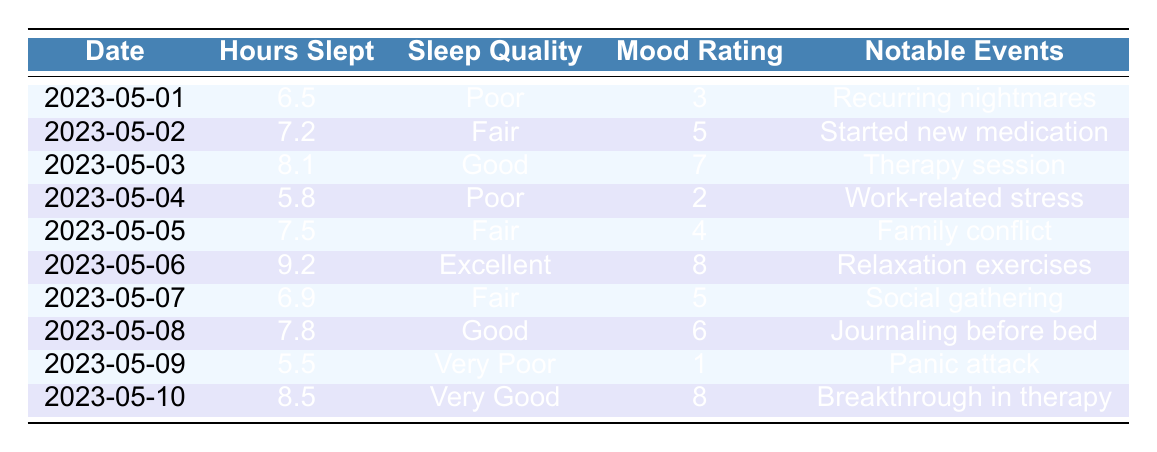What was the mood rating on May 6th? The table shows the entry for May 6th, where the mood rating is listed as 8.
Answer: 8 How many hours did the patient sleep on the nights with fair sleep quality? There are three entries with fair sleep quality: May 2nd (7.2 hours), May 5th (7.5 hours), and May 7th (6.9 hours). Summing these values gives 7.2 + 7.5 + 6.9 = 21.6 hours.
Answer: 21.6 Was there a deterioration in mood on the night with very poor sleep quality? On May 9th, the sleep quality is labeled as very poor and the mood rating is 1, indicating a significant deterioration.
Answer: Yes What was the average mood rating for the days when the patient slept more than 8 hours? The relevant dates where the patient slept more than 8 hours are May 6th (mood rating 8) and May 10th (mood rating 8). Adding them gives 8 + 8 = 16, and with two data entries, the average is 16/2 = 8.
Answer: 8 On how many days did notable events coincide with good or excellent sleep quality? Good sleep quality is noted on May 3rd (therapy session) and May 8th (journaling before bed). Excellent sleep quality is noted on May 6th (relaxation exercises). Therefore, there are three days in total that fit the criteria: May 3rd, 6th, and 8th.
Answer: 3 What change in sleep quality can be observed from May 5th to May 6th, and how did it affect the mood rating? On May 5th, sleep quality was fair, and the mood rating was 4. On May 6th, sleep quality improved to excellent, and the mood rating increased to 8. Thus, there was an improvement in both sleep quality and mood rating.
Answer: Improvement Did the patient have a notable event on the day with the highest sleep quality? Yes, on May 6th, when the sleep quality was excellent, the notable event was relaxation exercises.
Answer: Yes How many days in the data set had sleep quality rated as poor? The entries for poor sleep quality can be found on May 1st, 4th, and 9th, making a total of three days.
Answer: 3 